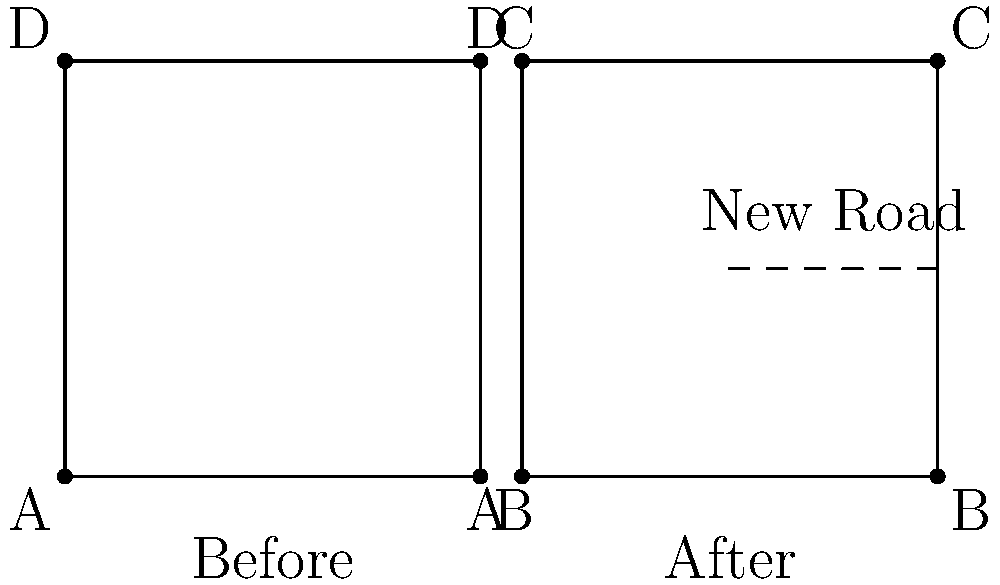Analyze the before-and-after network diagrams representing a small locality. How does the addition of the new road affect the network's connectivity, and what metric would best quantify this change? To analyze the effect of the new road on local connectivity, we need to consider the following steps:

1. Observe the initial network (before):
   - 4 nodes (A, B, C, D) connected in a square formation
   - 4 edges connecting these nodes

2. Observe the changed network (after):
   - Same 4 nodes (A, B, C, D)
   - 5 edges, including the new road connecting nodes B and D

3. Consider connectivity metrics:
   - Edge density: ratio of actual edges to potential edges
   - Before: $\frac{4}{\binom{4}{2}} = \frac{4}{6} \approx 0.67$
   - After: $\frac{5}{\binom{4}{2}} = \frac{5}{6} \approx 0.83$

4. Analyze the impact:
   - The new road increases direct connections between nodes
   - It creates a shortcut between B and D, reducing travel distances
   - The network becomes more resilient, offering alternative routes

5. Choose an appropriate metric:
   - Edge density effectively captures the increase in connectivity
   - It quantifies the proportion of possible connections that exist
   - The increase from 0.67 to 0.83 reflects improved connectivity

6. Consider other potential metrics:
   - Average path length would also decrease
   - Clustering coefficient might change

The edge density metric best quantifies this change as it directly measures the increase in connections relative to the total possible connections in the network.
Answer: Edge density 